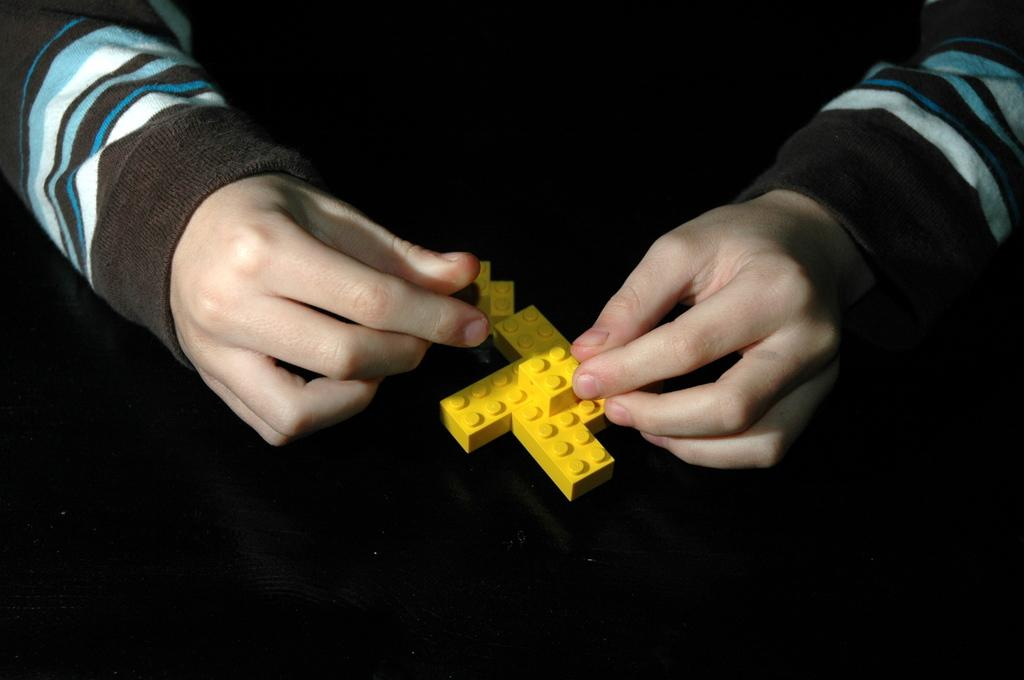What is visible in the image? There is a person's hand in the image. What is the hand holding? The hand is holding yellow color blocks. What type of mass is being used to create the yellow color blocks in the image? There is no information about the mass used to create the yellow color blocks in the image. What type of oil is being used to make the yellow color blocks in the image? There is no information about the oil used to make the yellow color blocks in the image. What type of lead is being used to create the yellow color blocks in the image? There is no information about the lead used to create the yellow color blocks in the image. 